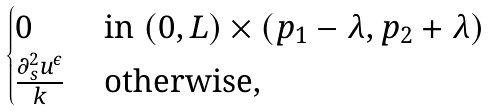<formula> <loc_0><loc_0><loc_500><loc_500>\begin{cases} 0 & \text { in } ( 0 , L ) \times ( p _ { 1 } - \lambda , p _ { 2 } + \lambda ) \\ \frac { \partial _ { s } ^ { 2 } u ^ { \epsilon } } { k } & \text { otherwise, } \end{cases}</formula> 